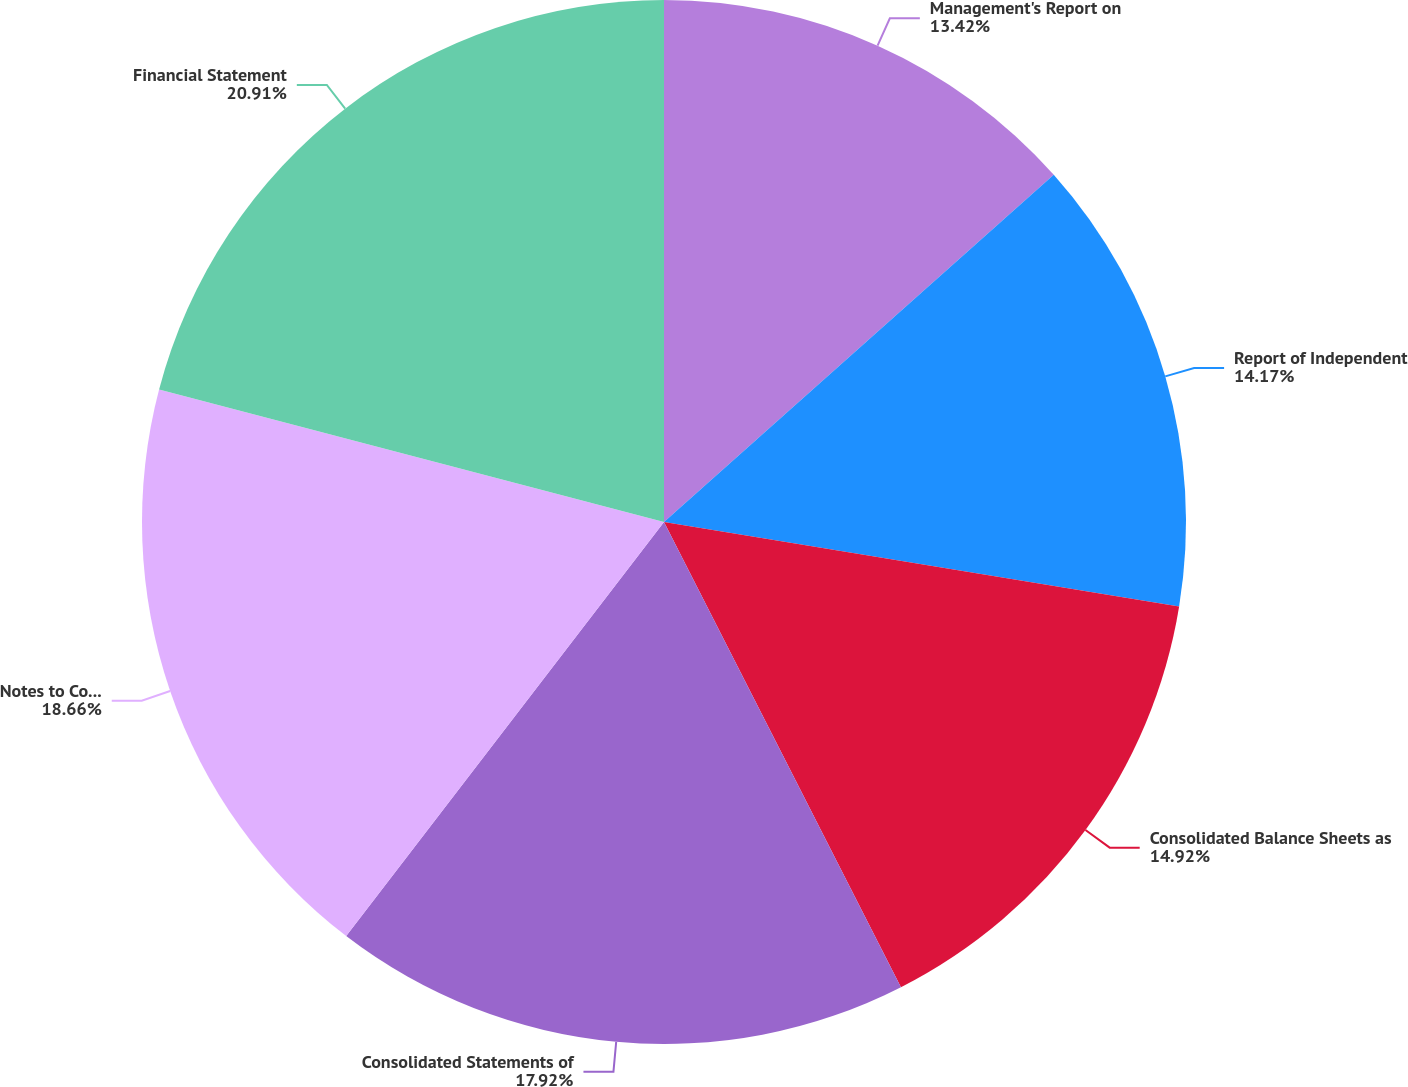Convert chart. <chart><loc_0><loc_0><loc_500><loc_500><pie_chart><fcel>Management's Report on<fcel>Report of Independent<fcel>Consolidated Balance Sheets as<fcel>Consolidated Statements of<fcel>Notes to Consolidated<fcel>Financial Statement<nl><fcel>13.42%<fcel>14.17%<fcel>14.92%<fcel>17.92%<fcel>18.67%<fcel>20.92%<nl></chart> 